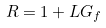Convert formula to latex. <formula><loc_0><loc_0><loc_500><loc_500>R = 1 + L G _ { f }</formula> 